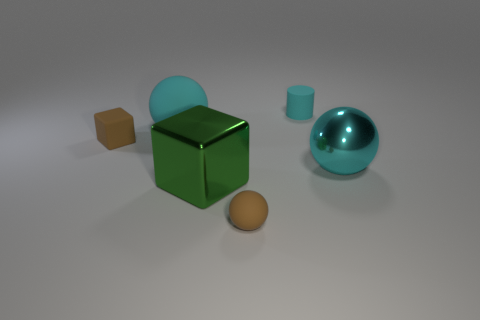Subtract all matte balls. How many balls are left? 1 Add 1 small brown rubber cubes. How many objects exist? 7 Subtract all brown cubes. How many cubes are left? 1 Subtract all brown cylinders. How many cyan balls are left? 2 Subtract all cubes. How many objects are left? 4 Subtract 2 blocks. How many blocks are left? 0 Subtract all yellow spheres. Subtract all gray cubes. How many spheres are left? 3 Subtract all tiny brown blocks. Subtract all spheres. How many objects are left? 2 Add 6 large cyan balls. How many large cyan balls are left? 8 Add 5 big green shiny spheres. How many big green shiny spheres exist? 5 